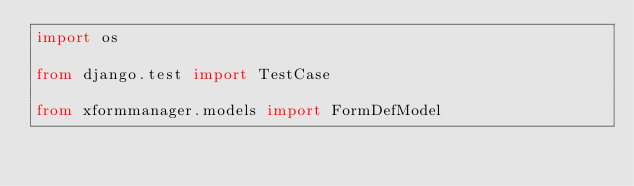<code> <loc_0><loc_0><loc_500><loc_500><_Python_>import os

from django.test import TestCase

from xformmanager.models import FormDefModel</code> 